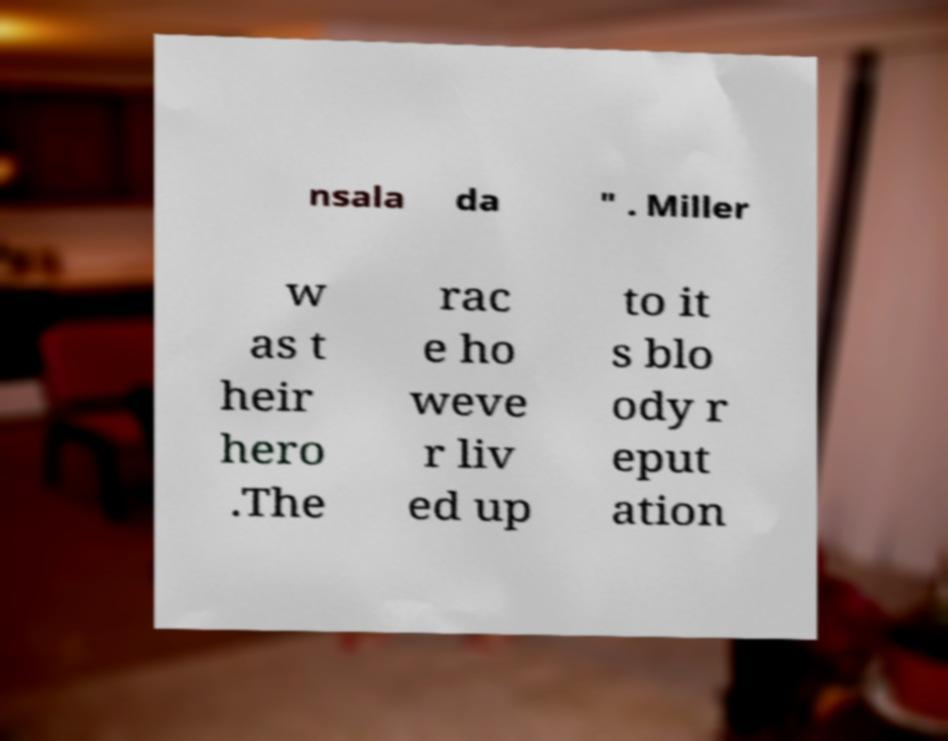Could you extract and type out the text from this image? nsala da " . Miller w as t heir hero .The rac e ho weve r liv ed up to it s blo ody r eput ation 